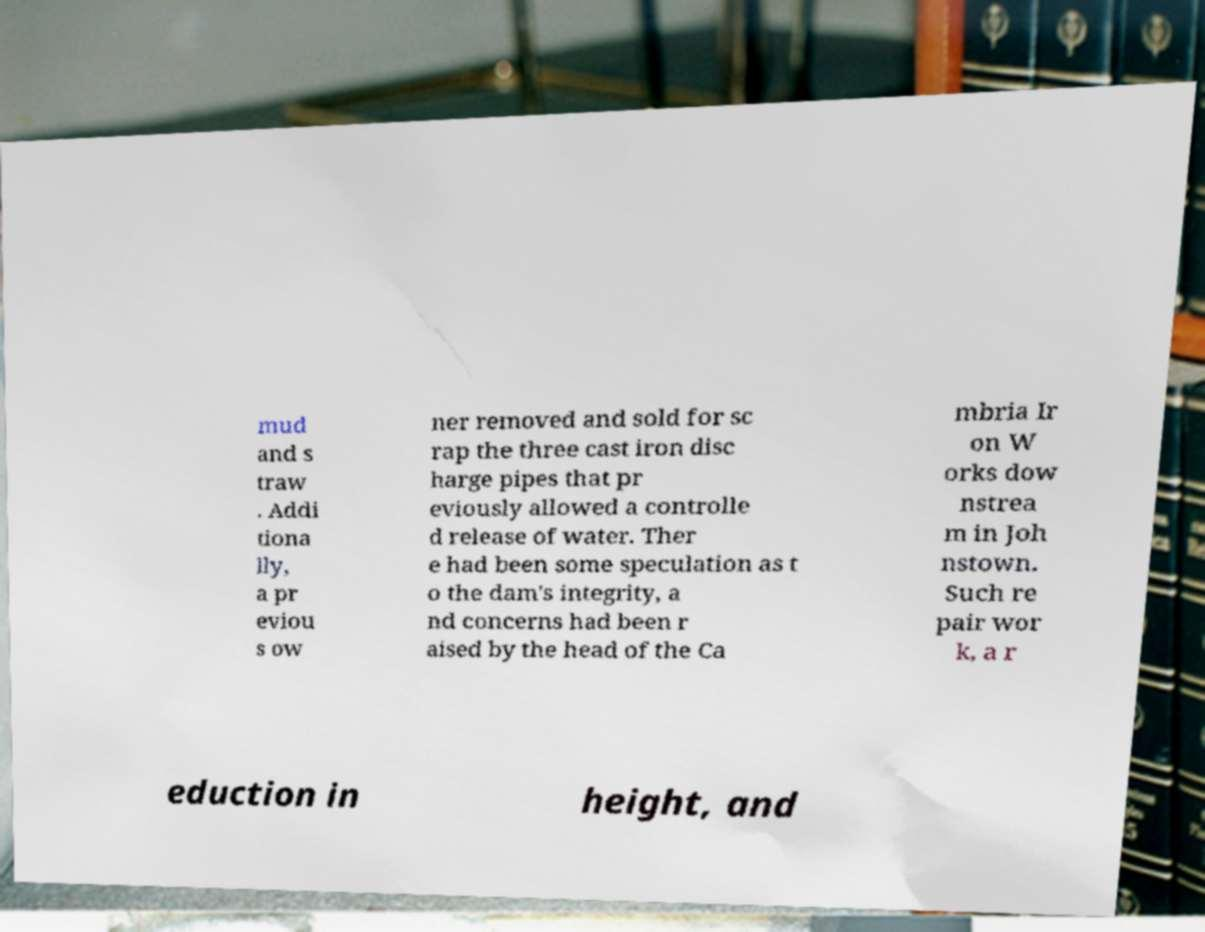Can you accurately transcribe the text from the provided image for me? mud and s traw . Addi tiona lly, a pr eviou s ow ner removed and sold for sc rap the three cast iron disc harge pipes that pr eviously allowed a controlle d release of water. Ther e had been some speculation as t o the dam's integrity, a nd concerns had been r aised by the head of the Ca mbria Ir on W orks dow nstrea m in Joh nstown. Such re pair wor k, a r eduction in height, and 